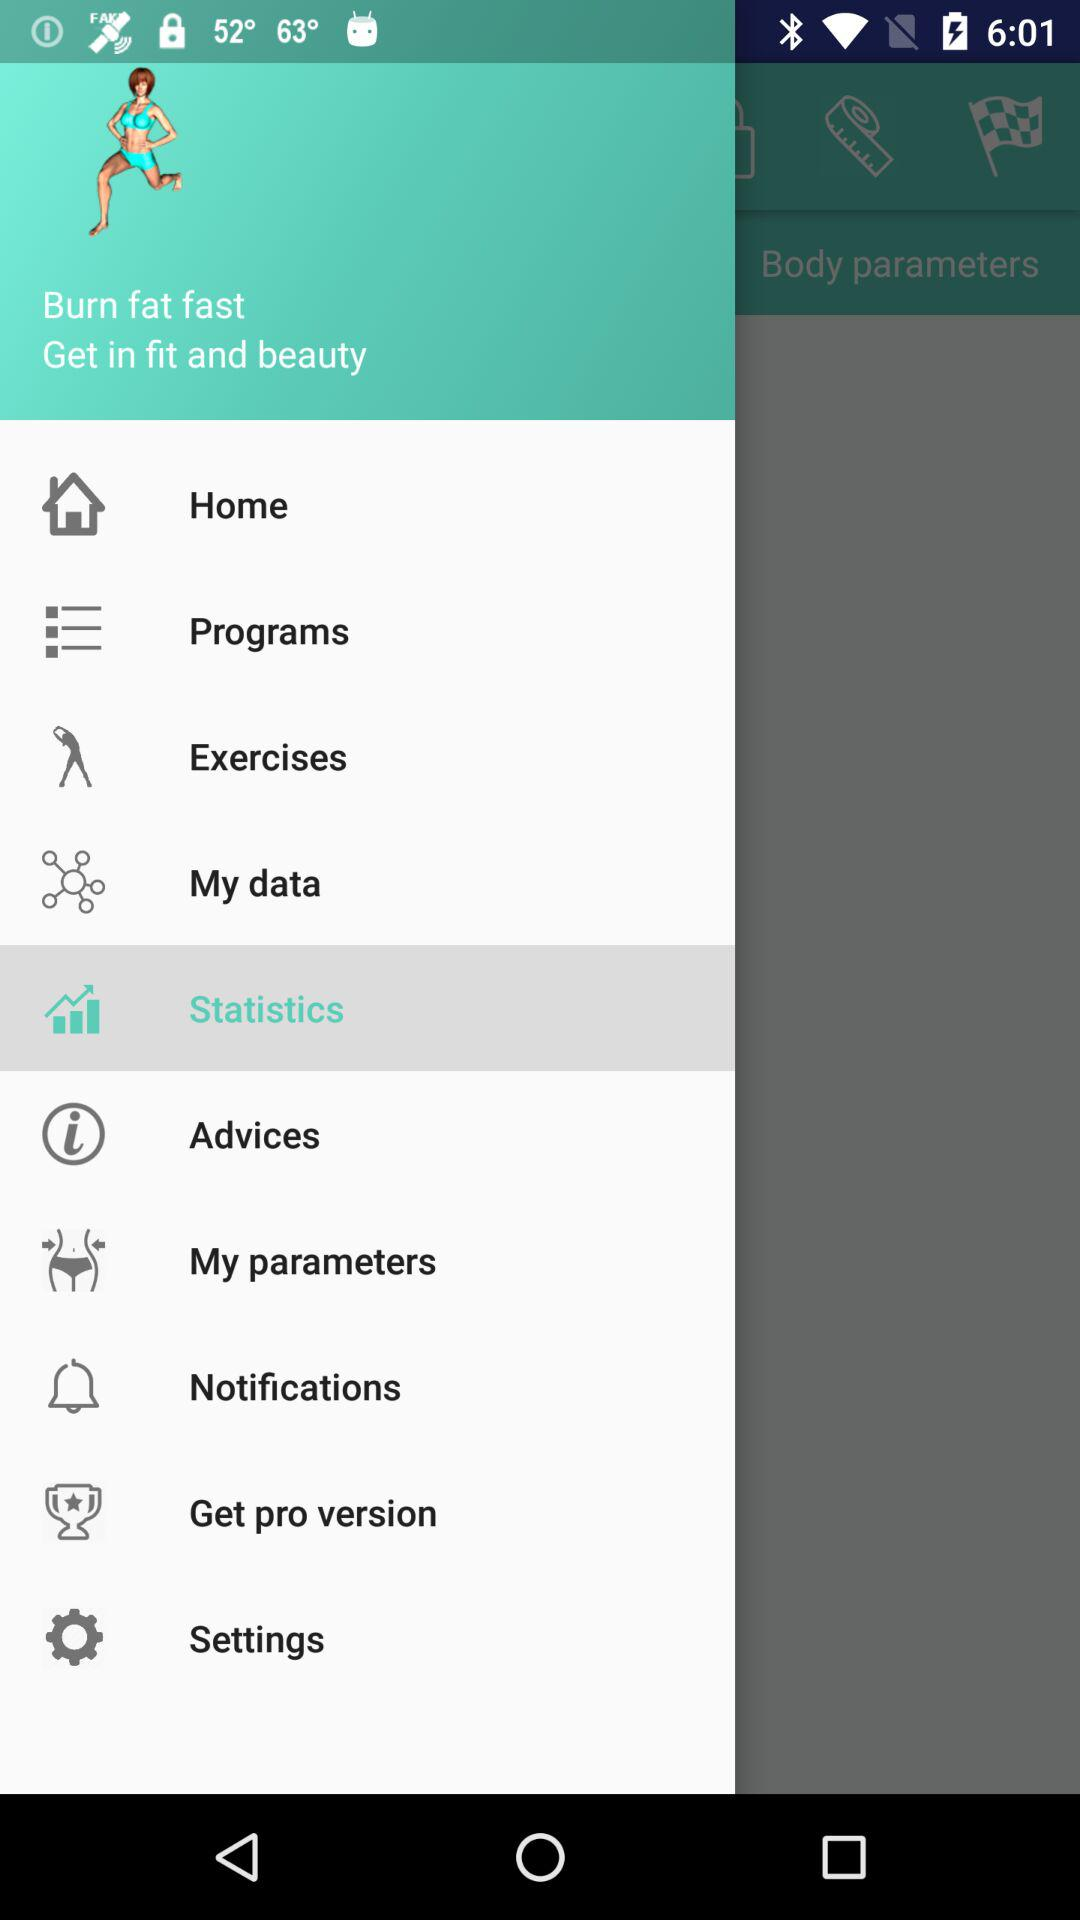What option is selected? The selected option is "Statistics". 